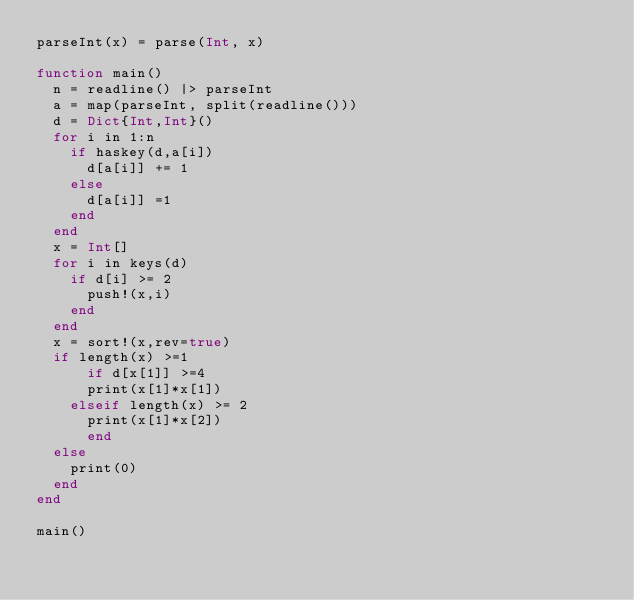Convert code to text. <code><loc_0><loc_0><loc_500><loc_500><_Julia_>parseInt(x) = parse(Int, x)

function main()
	n = readline() |> parseInt
	a = map(parseInt, split(readline()))
	d = Dict{Int,Int}()
	for i in 1:n
		if haskey(d,a[i])
			d[a[i]] += 1
		else
			d[a[i]] =1
		end
	end
	x = Int[]
	for i in keys(d)
		if d[i] >= 2
			push!(x,i)
		end
	end
	x = sort!(x,rev=true)
	if length(x) >=1
    	if d[x[1]] >=4
			print(x[1]*x[1])
		elseif length(x) >= 2
			print(x[1]*x[2])
    	end
	else
		print(0)
	end
end

main()</code> 